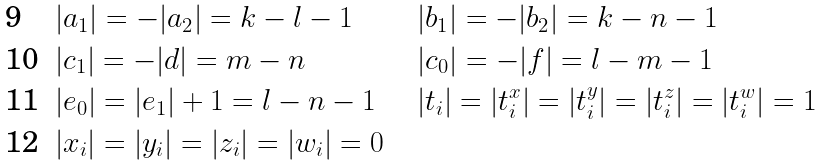<formula> <loc_0><loc_0><loc_500><loc_500>& | a _ { 1 } | = - | a _ { 2 } | = k - l - 1 & & & & | b _ { 1 } | = - | b _ { 2 } | = k - n - 1 \\ & | c _ { 1 } | = - | d | = m - n & & & & | c _ { 0 } | = - | f | = l - m - 1 & \\ & | e _ { 0 } | = | e _ { 1 } | + 1 = l - n - 1 & & & & | t _ { i } | = | t ^ { x } _ { i } | = | t ^ { y } _ { i } | = | t ^ { z } _ { i } | = | t ^ { w } _ { i } | = 1 \\ & | x _ { i } | = | y _ { i } | = | z _ { i } | = | w _ { i } | = 0</formula> 